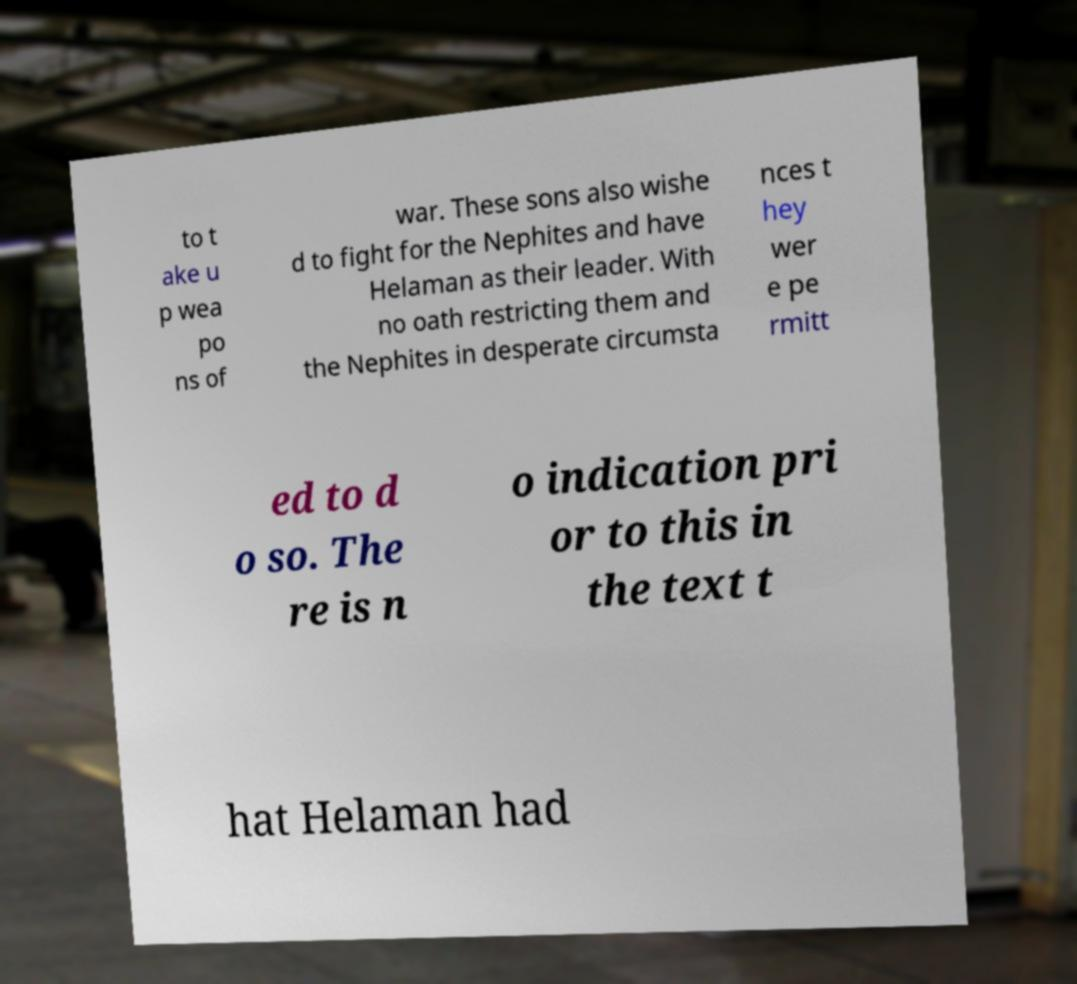There's text embedded in this image that I need extracted. Can you transcribe it verbatim? to t ake u p wea po ns of war. These sons also wishe d to fight for the Nephites and have Helaman as their leader. With no oath restricting them and the Nephites in desperate circumsta nces t hey wer e pe rmitt ed to d o so. The re is n o indication pri or to this in the text t hat Helaman had 